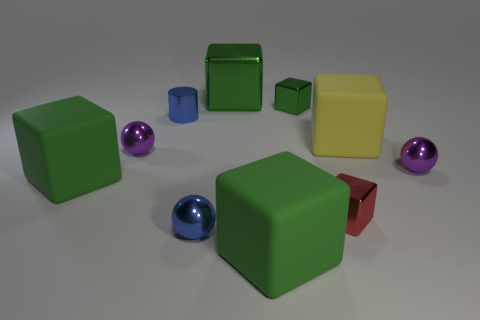Is there a tiny object of the same color as the metal cylinder?
Provide a succinct answer. Yes. The thing that is the same color as the cylinder is what size?
Offer a very short reply. Small. There is a tiny object that is the same color as the small metallic cylinder; what is its material?
Your answer should be compact. Metal. There is a thing that is on the right side of the big green metal thing and to the left of the small green shiny object; what is its size?
Ensure brevity in your answer.  Large. What number of matte things are either large red objects or large green blocks?
Provide a succinct answer. 2. Are there more purple balls to the right of the small green cube than blue balls?
Your answer should be compact. No. What material is the blue object that is on the right side of the tiny blue metallic cylinder?
Your answer should be very brief. Metal. What number of blue cylinders have the same material as the large yellow thing?
Provide a short and direct response. 0. What shape is the thing that is in front of the yellow matte object and on the right side of the small red metal object?
Offer a terse response. Sphere. What number of things are small blue things that are in front of the red metal object or purple spheres that are right of the small cylinder?
Ensure brevity in your answer.  2. 